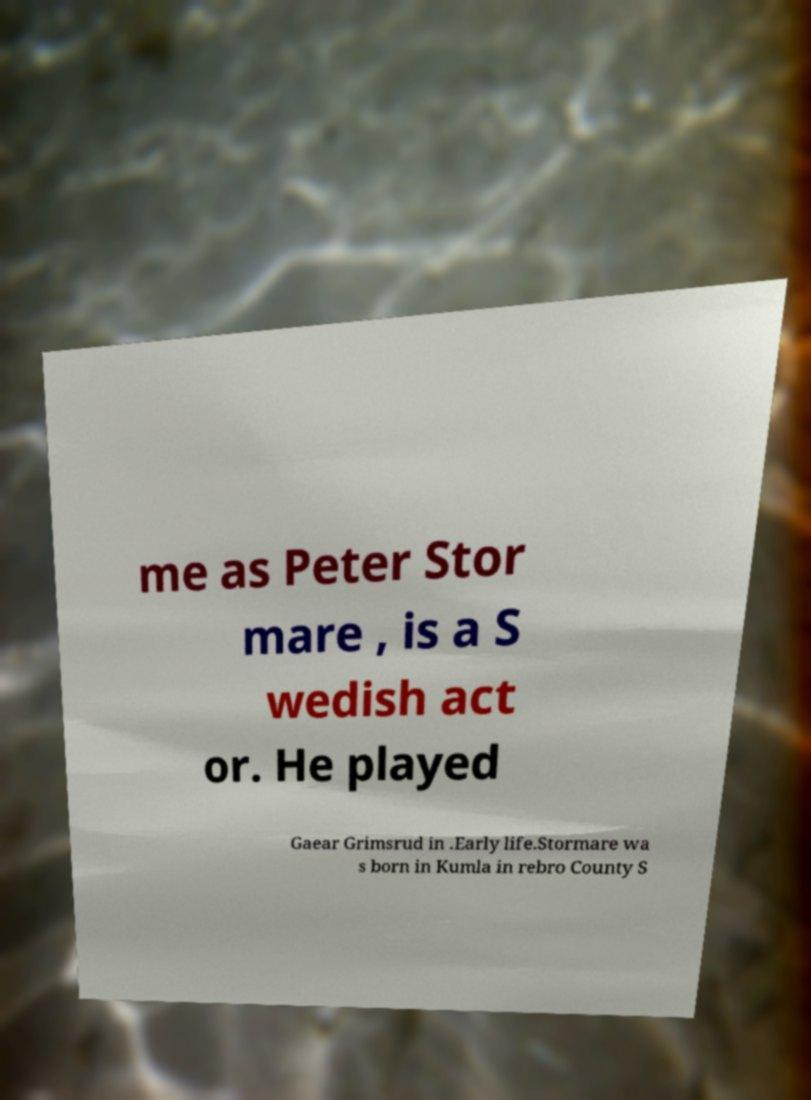Can you accurately transcribe the text from the provided image for me? me as Peter Stor mare , is a S wedish act or. He played Gaear Grimsrud in .Early life.Stormare wa s born in Kumla in rebro County S 